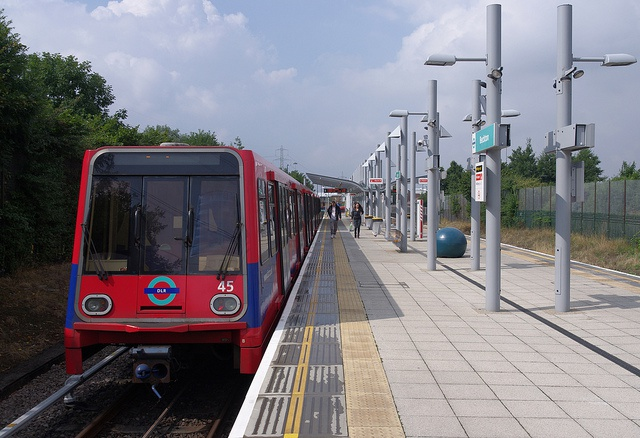Describe the objects in this image and their specific colors. I can see train in lavender, black, gray, and brown tones, people in lavender, black, and gray tones, and people in lavender, black, and gray tones in this image. 